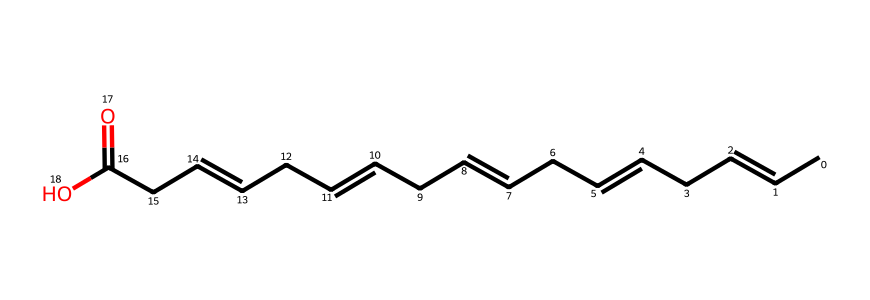What is the molecular formula of this compound? To determine the molecular formula, count the number of carbon (C), hydrogen (H), and oxygen (O) atoms in the given structure. From the SMILES representation, there are 18 carbons, 34 hydrogens, and 2 oxygens. The molecular formula is thus C18H34O2.
Answer: C18H34O2 How many double bonds are present in this fatty acid? By analyzing the structure, count the number of '=' signs in the SMILES string, which represent the double bonds. In this compound, there are five '=' signs indicating five double bonds.
Answer: 5 What type of lipid does this structure represent? The presence of long carbon chains and carboxylic acid (-COOH) functional group in the structure suggests this compound is a fatty acid. Since it contains multiple double bonds, it is classified as a polyunsaturated fatty acid.
Answer: polyunsaturated fatty acid What is the significance of the double bonds in this fatty acid? The double bonds introduce kinks in the hydrocarbon chain, affecting the physical properties of the fatty acid, such as its melting point and fluidity. This is significant for its role in biological membranes and health benefits associated with omega-3 fatty acids.
Answer: kinks What function does the carboxylic acid group serve in this structure? The carboxylic acid (-COOH) group makes the compound behave as an acid, allowing it to participate in various chemical reactions, such as forming esters or being involved in metabolic pathways. It is crucial for its biochemical properties.
Answer: acid behavior What type of chemical reaction is likely to occur with this fatty acid in the presence of an amine? The reaction between a fatty acid and an amine can lead to the formation of an amide through a condensation reaction, where water is released as a byproduct.
Answer: amide formation What is a common dietary source of this fatty acid? Omega-3 fatty acids are commonly found in fish, particularly fatty fish like salmon, mackerel, and sardines, which are rich in fish oil supplements.
Answer: fish 